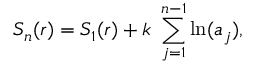Convert formula to latex. <formula><loc_0><loc_0><loc_500><loc_500>S _ { n } ( r ) = S _ { 1 } ( r ) + k \ \sum _ { j = 1 } ^ { n - 1 } \ln ( a _ { j } ) ,</formula> 